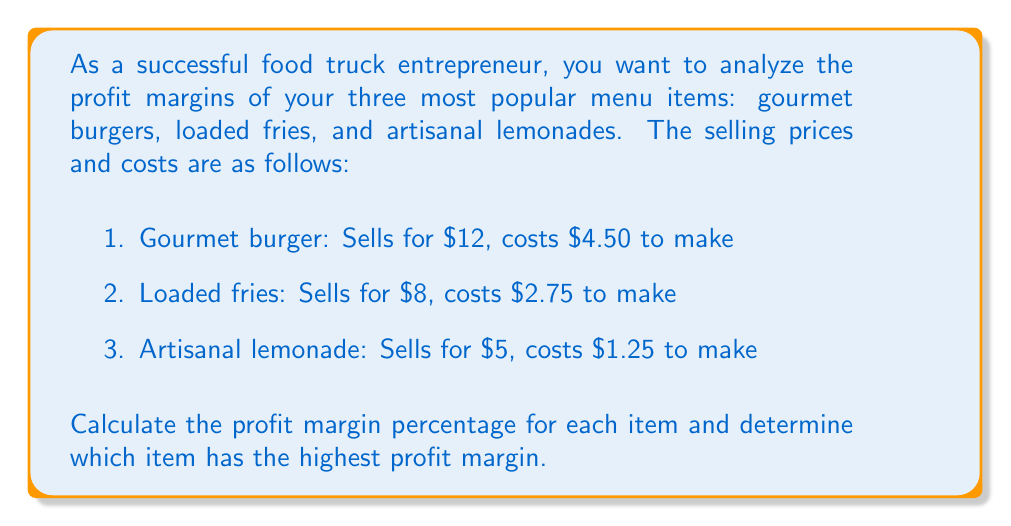Teach me how to tackle this problem. To solve this problem, we'll follow these steps:

1. Calculate the profit for each item
2. Calculate the profit margin percentage for each item
3. Compare the profit margin percentages

Step 1: Calculate the profit for each item

Profit is calculated by subtracting the cost from the selling price.

For gourmet burger:
$$ \text{Profit}_{\text{burger}} = $12 - $4.50 = $7.50 $$

For loaded fries:
$$ \text{Profit}_{\text{fries}} = $8 - $2.75 = $5.25 $$

For artisanal lemonade:
$$ \text{Profit}_{\text{lemonade}} = $5 - $1.25 = $3.75 $$

Step 2: Calculate the profit margin percentage for each item

The profit margin percentage is calculated using the formula:

$$ \text{Profit Margin} = \frac{\text{Profit}}{\text{Selling Price}} \times 100\% $$

For gourmet burger:
$$ \text{Profit Margin}_{\text{burger}} = \frac{$7.50}{$12} \times 100\% = 62.5\% $$

For loaded fries:
$$ \text{Profit Margin}_{\text{fries}} = \frac{$5.25}{$8} \times 100\% = 65.625\% $$

For artisanal lemonade:
$$ \text{Profit Margin}_{\text{lemonade}} = \frac{$3.75}{$5} \times 100\% = 75\% $$

Step 3: Compare the profit margin percentages

Comparing the profit margin percentages:
- Gourmet burger: 62.5%
- Loaded fries: 65.625%
- Artisanal lemonade: 75%

The artisanal lemonade has the highest profit margin at 75%.
Answer: The profit margin percentages are:
- Gourmet burger: 62.5%
- Loaded fries: 65.625%
- Artisanal lemonade: 75%

The artisanal lemonade has the highest profit margin at 75%. 